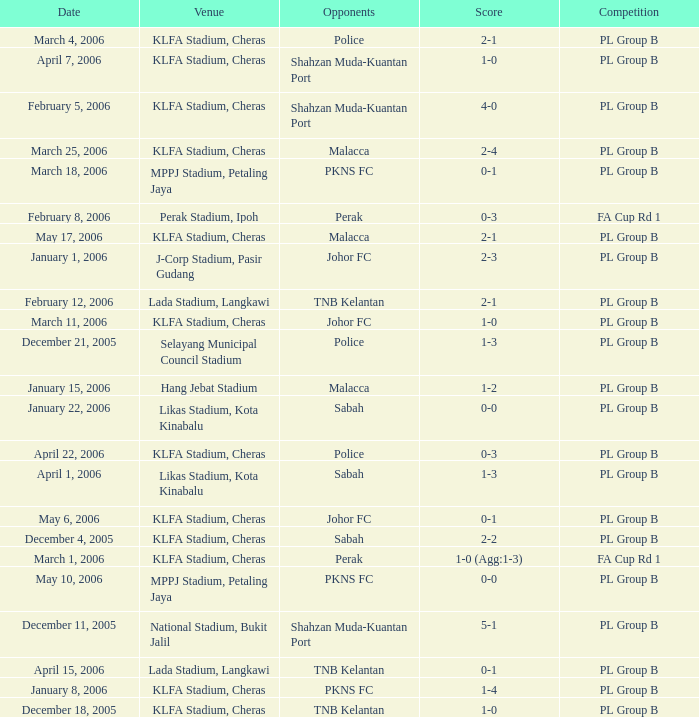Which Competition has a Score of 0-1, and Opponents of pkns fc? PL Group B. 